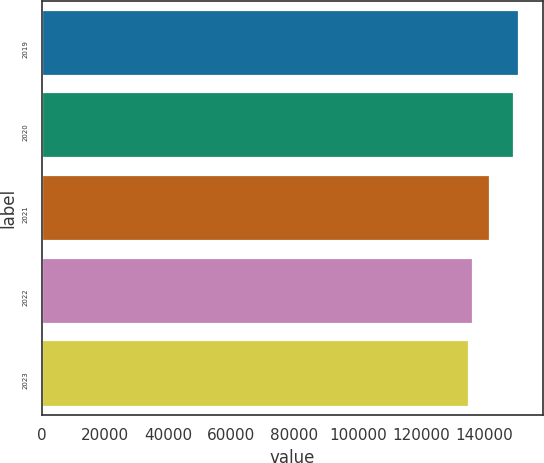<chart> <loc_0><loc_0><loc_500><loc_500><bar_chart><fcel>2019<fcel>2020<fcel>2021<fcel>2022<fcel>2023<nl><fcel>151010<fcel>149500<fcel>141900<fcel>136610<fcel>135100<nl></chart> 